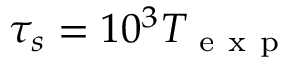<formula> <loc_0><loc_0><loc_500><loc_500>\tau _ { s } = 1 0 ^ { 3 } T _ { e x p }</formula> 